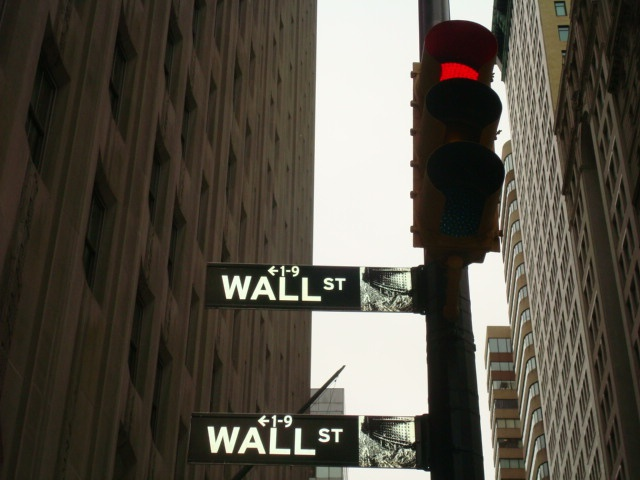Describe the objects in this image and their specific colors. I can see a traffic light in black, maroon, red, and white tones in this image. 